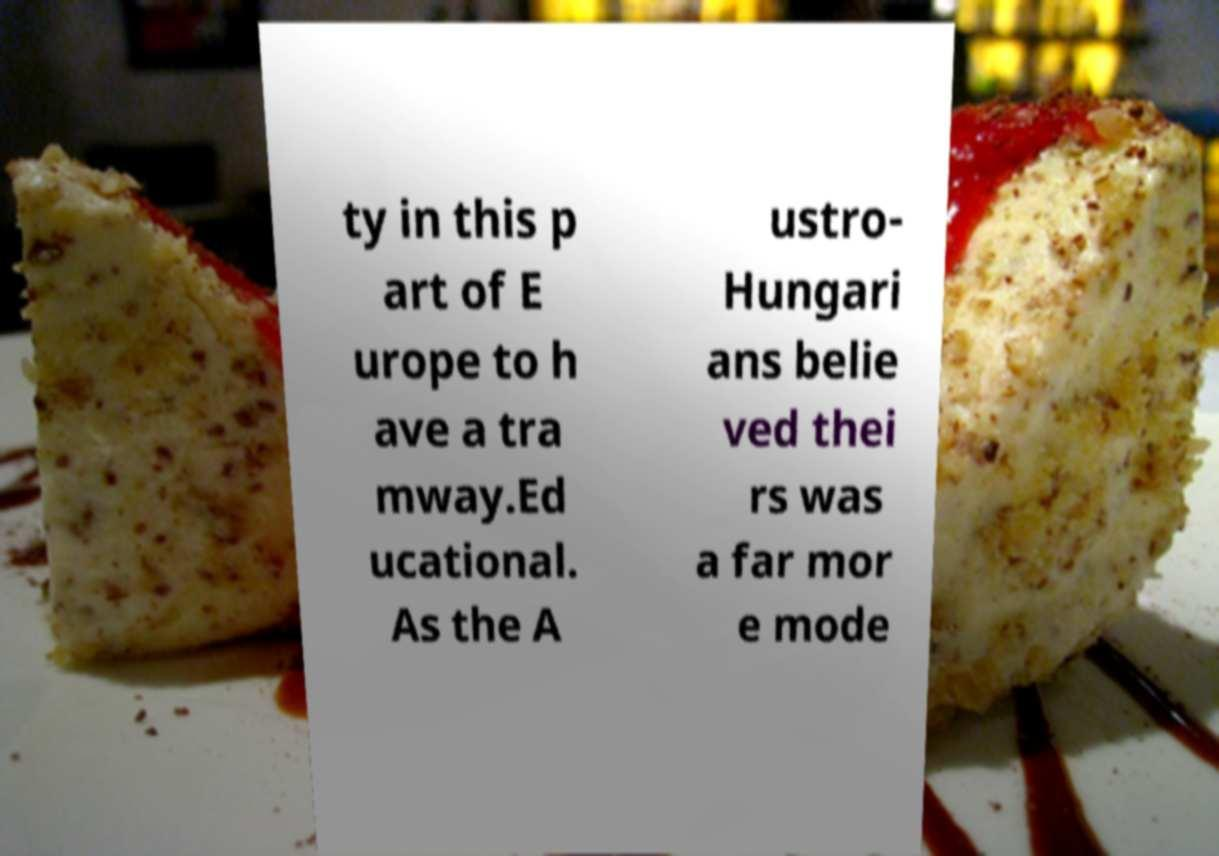There's text embedded in this image that I need extracted. Can you transcribe it verbatim? ty in this p art of E urope to h ave a tra mway.Ed ucational. As the A ustro- Hungari ans belie ved thei rs was a far mor e mode 